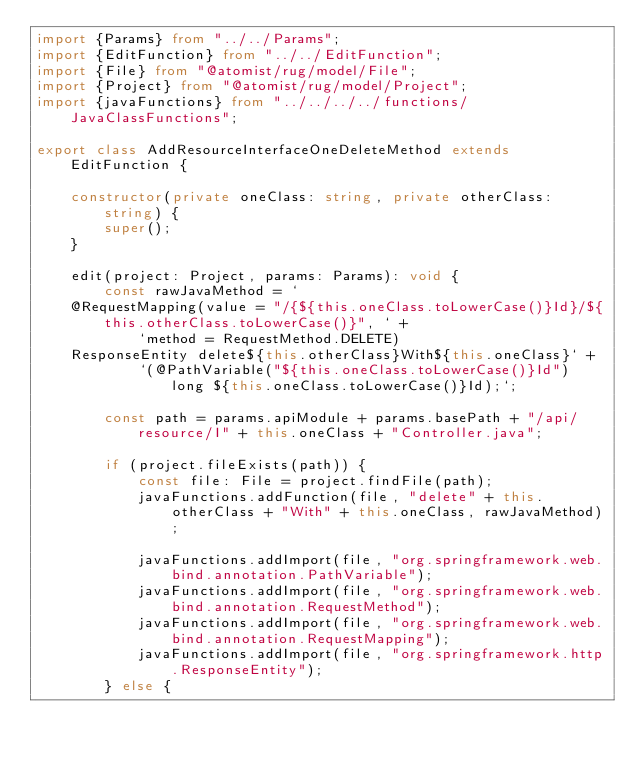<code> <loc_0><loc_0><loc_500><loc_500><_TypeScript_>import {Params} from "../../Params";
import {EditFunction} from "../../EditFunction";
import {File} from "@atomist/rug/model/File";
import {Project} from "@atomist/rug/model/Project";
import {javaFunctions} from "../../../../functions/JavaClassFunctions";

export class AddResourceInterfaceOneDeleteMethod extends EditFunction {

    constructor(private oneClass: string, private otherClass: string) {
        super();
    }

    edit(project: Project, params: Params): void {
        const rawJavaMethod = `
    @RequestMapping(value = "/{${this.oneClass.toLowerCase()}Id}/${this.otherClass.toLowerCase()}", ` +
            `method = RequestMethod.DELETE)
    ResponseEntity delete${this.otherClass}With${this.oneClass}` +
            `(@PathVariable("${this.oneClass.toLowerCase()}Id") long ${this.oneClass.toLowerCase()}Id);`;

        const path = params.apiModule + params.basePath + "/api/resource/I" + this.oneClass + "Controller.java";

        if (project.fileExists(path)) {
            const file: File = project.findFile(path);
            javaFunctions.addFunction(file, "delete" + this.otherClass + "With" + this.oneClass, rawJavaMethod);

            javaFunctions.addImport(file, "org.springframework.web.bind.annotation.PathVariable");
            javaFunctions.addImport(file, "org.springframework.web.bind.annotation.RequestMethod");
            javaFunctions.addImport(file, "org.springframework.web.bind.annotation.RequestMapping");
            javaFunctions.addImport(file, "org.springframework.http.ResponseEntity");
        } else {</code> 